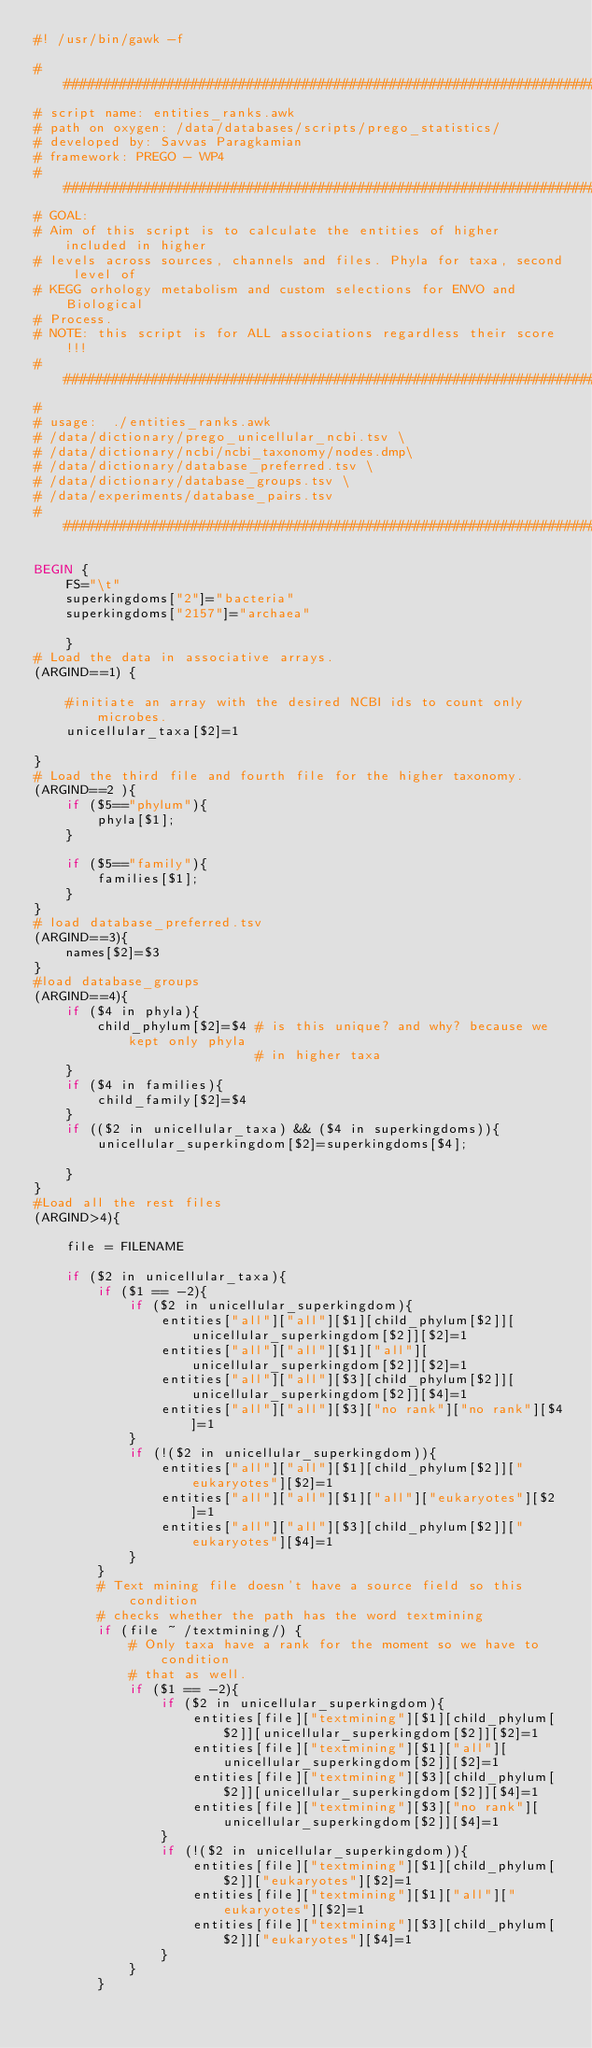<code> <loc_0><loc_0><loc_500><loc_500><_Awk_>#! /usr/bin/gawk -f

###############################################################################
# script name: entities_ranks.awk
# path on oxygen: /data/databases/scripts/prego_statistics/
# developed by: Savvas Paragkamian
# framework: PREGO - WP4
###############################################################################
# GOAL:
# Aim of this script is to calculate the entities of higher included in higher 
# levels across sources, channels and files. Phyla for taxa, second level of
# KEGG orhology metabolism and custom selections for ENVO and Biological 
# Process.
# NOTE: this script is for ALL associations regardless their score!!!
###############################################################################
#
# usage:  ./entities_ranks.awk 
# /data/dictionary/prego_unicellular_ncbi.tsv \
# /data/dictionary/ncbi/ncbi_taxonomy/nodes.dmp\ 
# /data/dictionary/database_preferred.tsv \
# /data/dictionary/database_groups.tsv \
# /data/experiments/database_pairs.tsv
###############################################################################

BEGIN {
    FS="\t"
    superkingdoms["2"]="bacteria"
    superkingdoms["2157"]="archaea"

    }
# Load the data in associative arrays.
(ARGIND==1) {

    #initiate an array with the desired NCBI ids to count only microbes.
    unicellular_taxa[$2]=1

}
# Load the third file and fourth file for the higher taxonomy.
(ARGIND==2 ){
    if ($5=="phylum"){
        phyla[$1];
    }
    
    if ($5=="family"){
        families[$1];
    }
}
# load database_preferred.tsv
(ARGIND==3){
    names[$2]=$3
}
#load database_groups
(ARGIND==4){
    if ($4 in phyla){
        child_phylum[$2]=$4 # is this unique? and why? because we kept only phyla
                            # in higher taxa
    }
    if ($4 in families){
        child_family[$2]=$4
    }
    if (($2 in unicellular_taxa) && ($4 in superkingdoms)){
        unicellular_superkingdom[$2]=superkingdoms[$4];

    }
}
#Load all the rest files
(ARGIND>4){

    file = FILENAME

    if ($2 in unicellular_taxa){
        if ($1 == -2){
            if ($2 in unicellular_superkingdom){
                entities["all"]["all"][$1][child_phylum[$2]][unicellular_superkingdom[$2]][$2]=1
                entities["all"]["all"][$1]["all"][unicellular_superkingdom[$2]][$2]=1
                entities["all"]["all"][$3][child_phylum[$2]][unicellular_superkingdom[$2]][$4]=1
                entities["all"]["all"][$3]["no rank"]["no rank"][$4]=1
            }
            if (!($2 in unicellular_superkingdom)){
                entities["all"]["all"][$1][child_phylum[$2]]["eukaryotes"][$2]=1
                entities["all"]["all"][$1]["all"]["eukaryotes"][$2]=1
                entities["all"]["all"][$3][child_phylum[$2]]["eukaryotes"][$4]=1
            }
        }
        # Text mining file doesn't have a source field so this condition
        # checks whether the path has the word textmining
        if (file ~ /textmining/) {
            # Only taxa have a rank for the moment so we have to condition
            # that as well.
            if ($1 == -2){
                if ($2 in unicellular_superkingdom){
                    entities[file]["textmining"][$1][child_phylum[$2]][unicellular_superkingdom[$2]][$2]=1
                    entities[file]["textmining"][$1]["all"][unicellular_superkingdom[$2]][$2]=1
                    entities[file]["textmining"][$3][child_phylum[$2]][unicellular_superkingdom[$2]][$4]=1
                    entities[file]["textmining"][$3]["no rank"][unicellular_superkingdom[$2]][$4]=1
                } 
                if (!($2 in unicellular_superkingdom)){
                    entities[file]["textmining"][$1][child_phylum[$2]]["eukaryotes"][$2]=1
                    entities[file]["textmining"][$1]["all"]["eukaryotes"][$2]=1
                    entities[file]["textmining"][$3][child_phylum[$2]]["eukaryotes"][$4]=1
                }
            }
        }</code> 